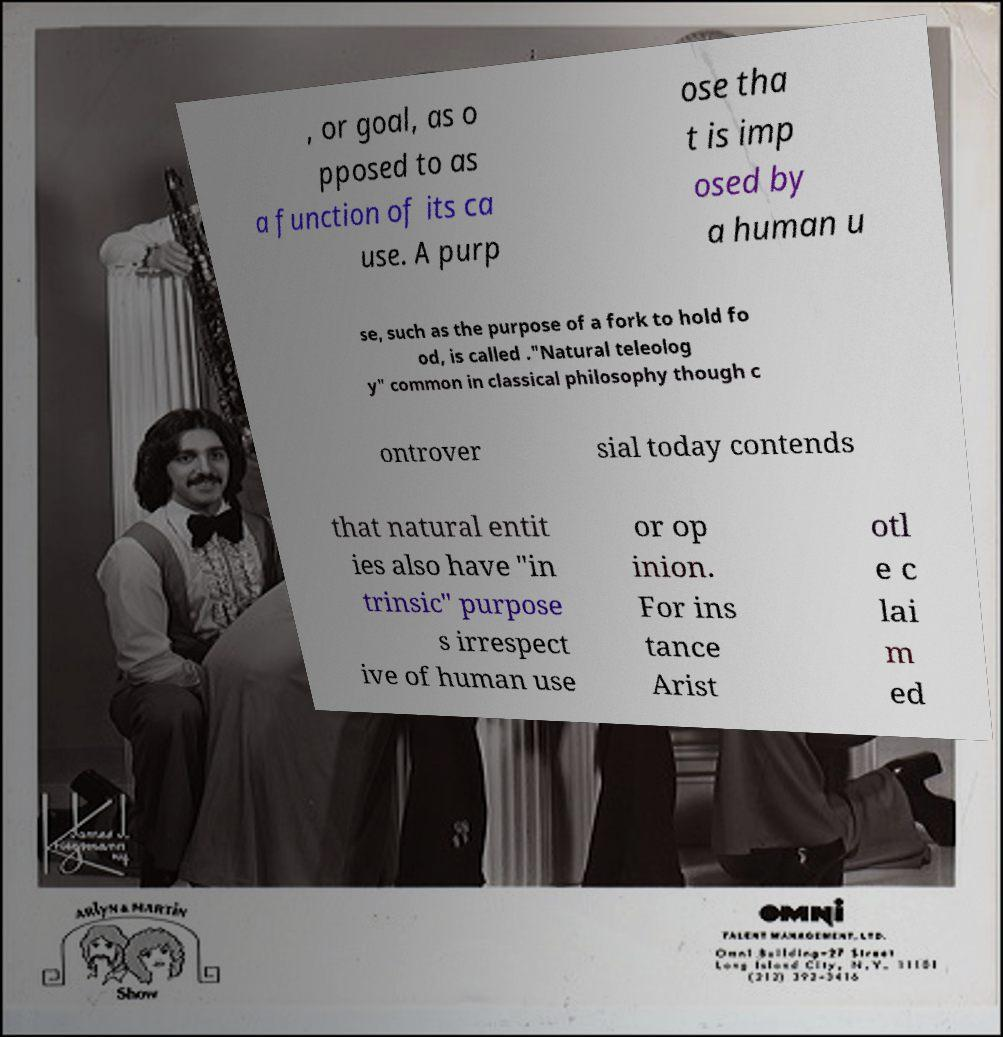Please read and relay the text visible in this image. What does it say? , or goal, as o pposed to as a function of its ca use. A purp ose tha t is imp osed by a human u se, such as the purpose of a fork to hold fo od, is called ."Natural teleolog y" common in classical philosophy though c ontrover sial today contends that natural entit ies also have "in trinsic" purpose s irrespect ive of human use or op inion. For ins tance Arist otl e c lai m ed 